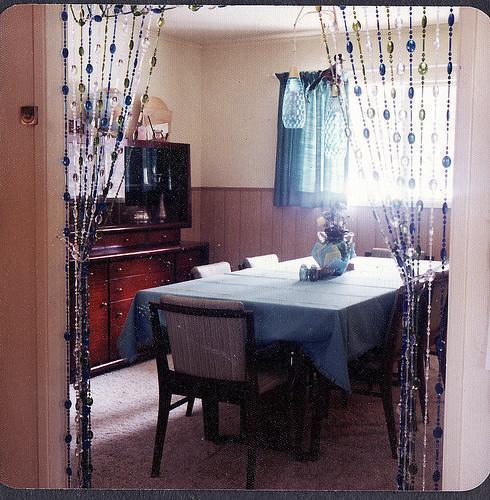How many chairs can you see?
Give a very brief answer. 6. How many chairs are in the photo?
Give a very brief answer. 2. How many tvs can be seen?
Give a very brief answer. 1. 